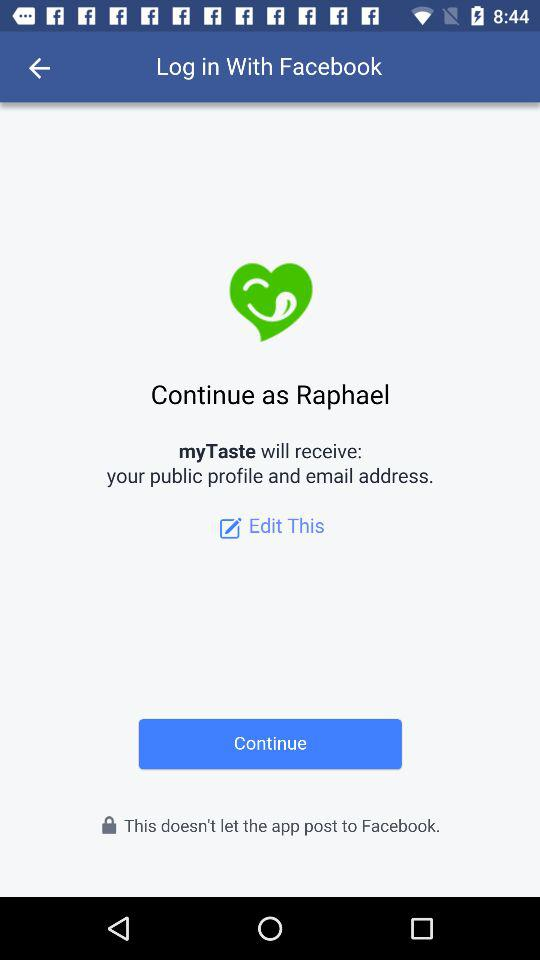What is the user name? The user name is Raphael. 